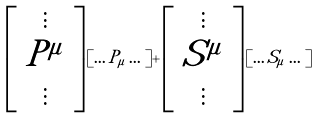Convert formula to latex. <formula><loc_0><loc_0><loc_500><loc_500>\left [ \begin{array} { c } \vdots \\ P ^ { \mu } \\ \vdots \end{array} \right ] [ \dots P _ { \mu } \dots ] + \left [ \begin{array} { c } \vdots \\ S ^ { \mu } \\ \vdots \end{array} \right ] [ \dots S _ { \mu } \dots ]</formula> 